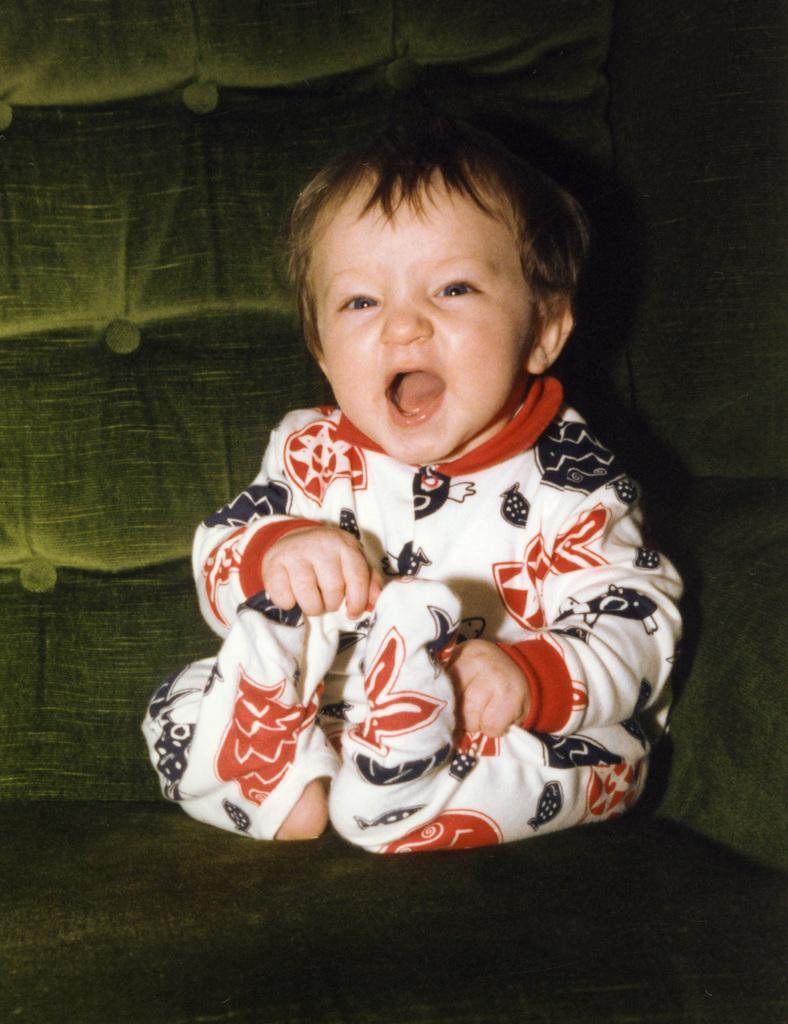Please provide a concise description of this image. In the center of the image we can see kid on the sofa. 